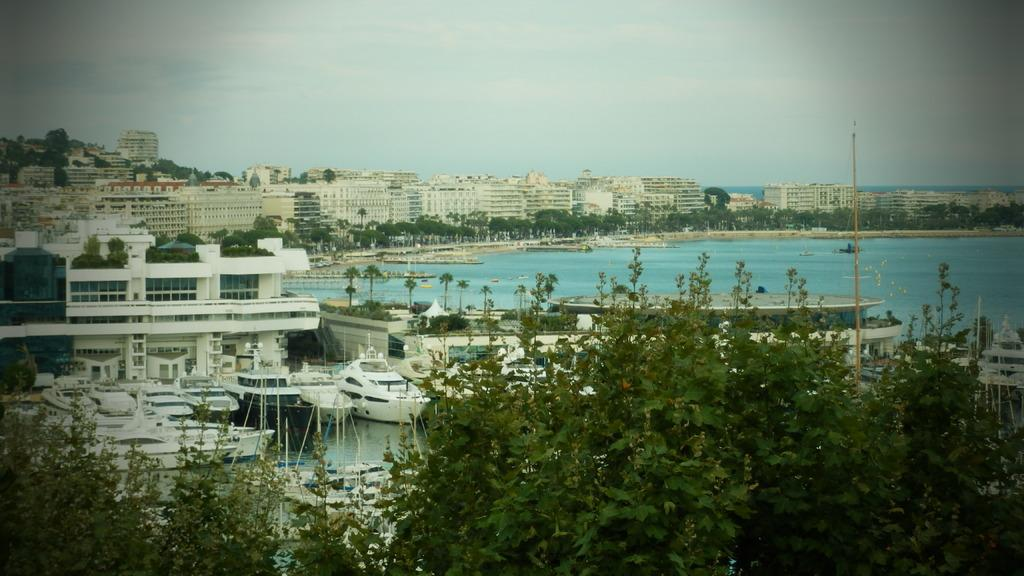What type of structures can be seen in the image? There are buildings in the image. What other natural elements are present in the image? There are trees in the image. What is happening on the water in the image? There are boats sailing on the water in the image. What type of water body is visible on the right side of the image? There is an ocean on the right side of the image. What is the condition of the sky in the image? The sky is clear in the image. What is the title of the book that is being read by the tail on the left side of the image? There is no book or tail present in the image. How does the twist in the story affect the characters in the image? There is no story or characters present in the image, so it is not possible to discuss the effects of a twist. 